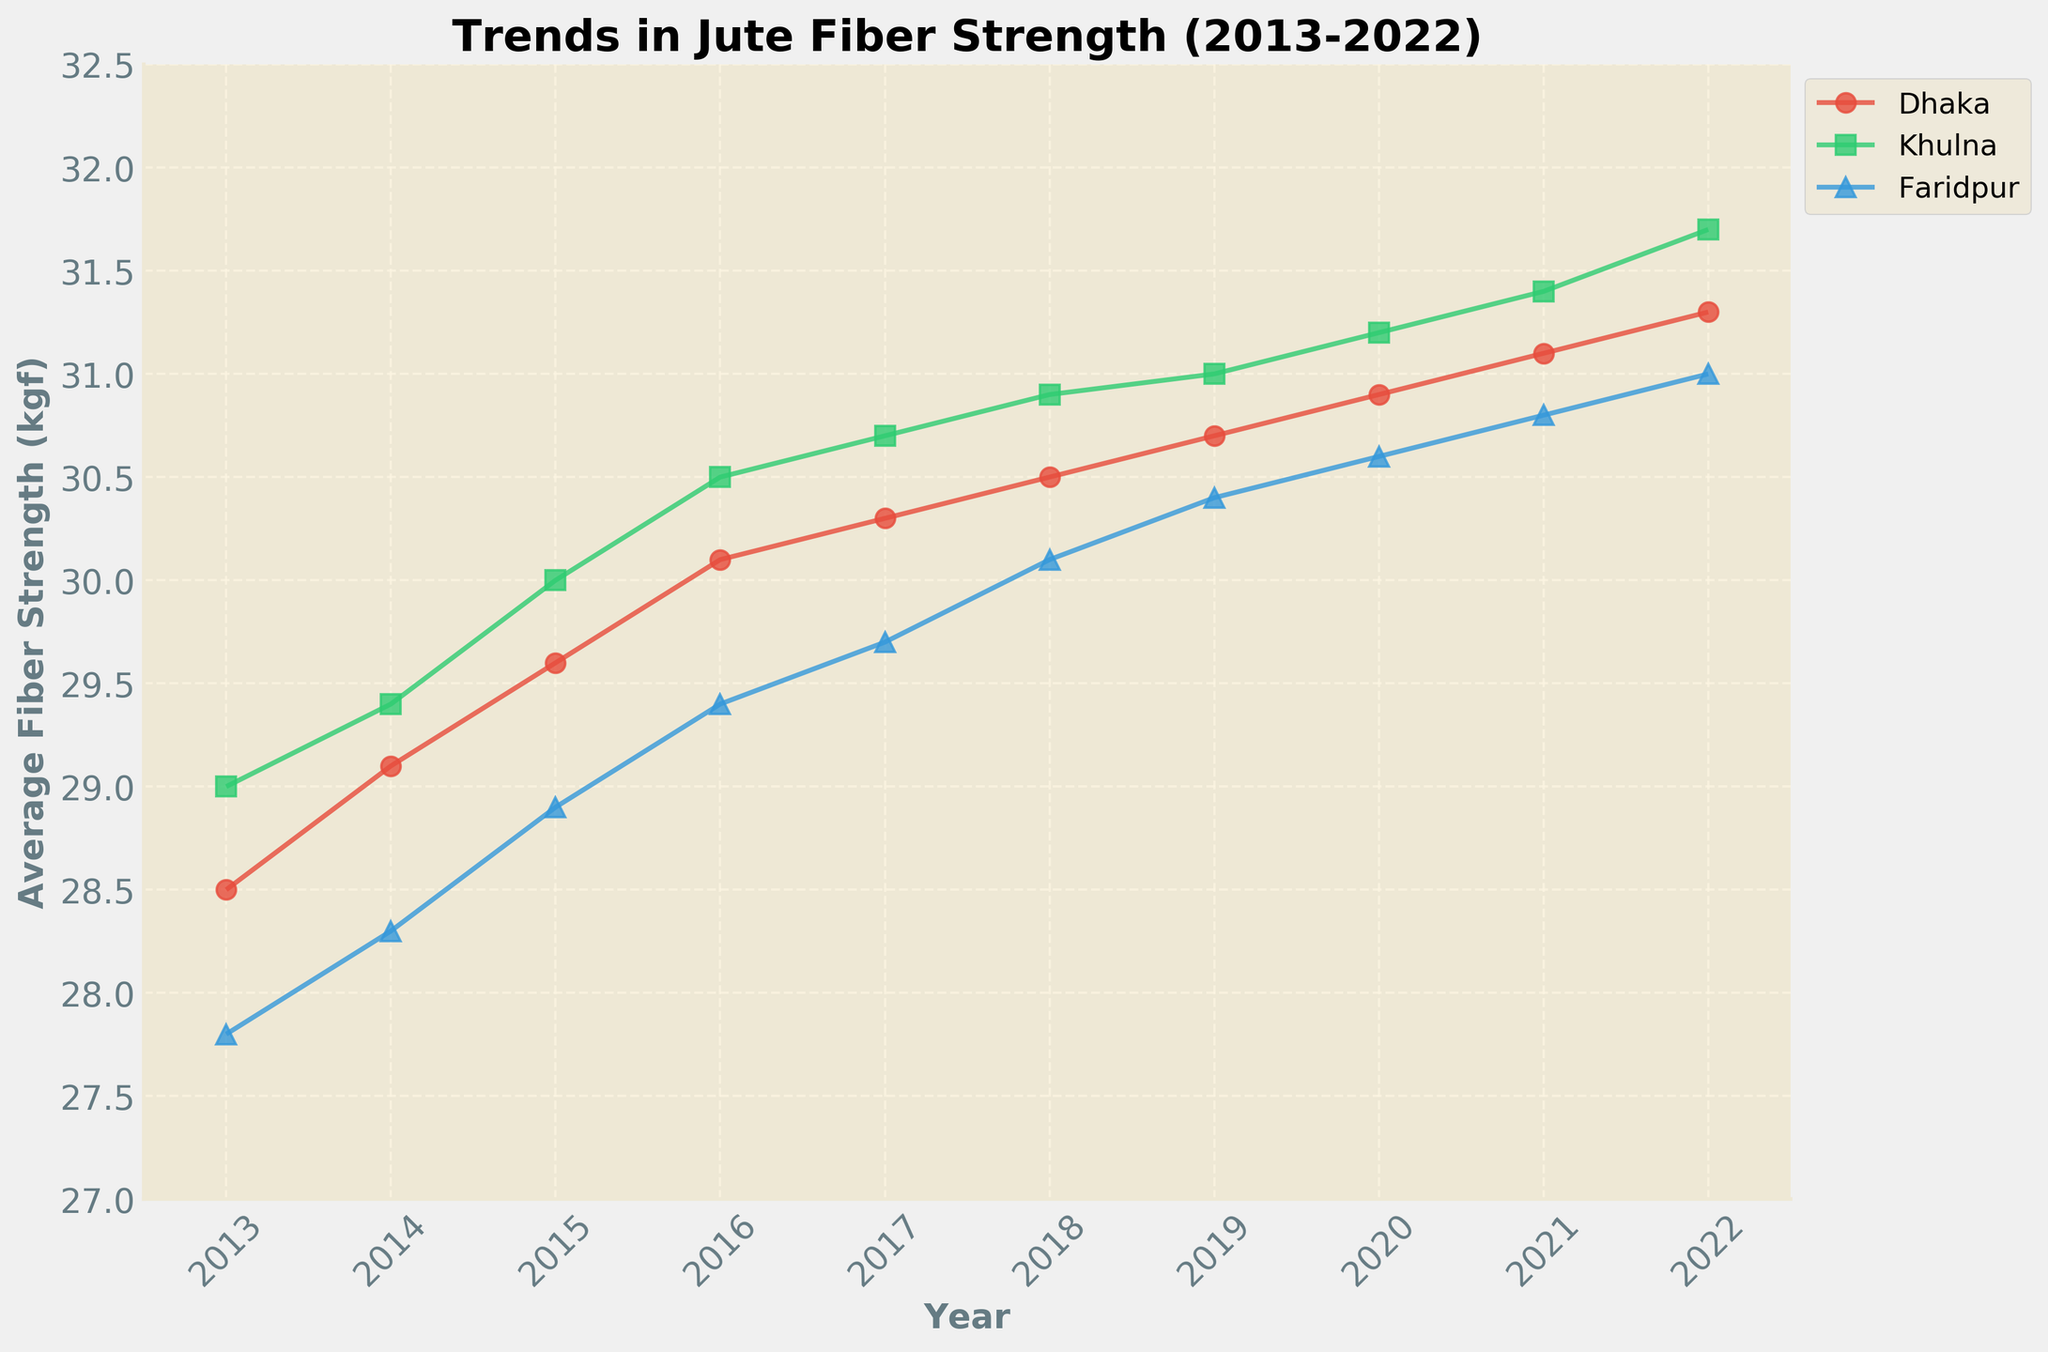What is the title of the figure? The title usually appears at the top of the figure, summarizing the main topic of the plot. In this case, the title indicates the trend of jute fiber strength over several years.
Answer: Trends in Jute Fiber Strength (2013-2022) Which region had the highest average fiber strength in 2022? To find this, observe the values for 2022 and compare the fiber strength values for Dhaka, Khulna, and Faridpur.
Answer: Khulna How did the average fiber strength in Dhaka change from 2013 to 2022? Check the data points for Dhaka in 2013 and 2022 and calculate the difference in their fiber strength.
Answer: It increased from 28.5 kgf in 2013 to 31.3 kgf in 2022 Which region shows the most consistent increase in fiber strength over the years? Look at the trend lines for each region from 2013 to 2022 and determine which one has the most uniform slope.
Answer: Khulna In which year did Faridpur first reach an average fiber strength of 30 kgf or more? Examine Faridpur’s trend line and identify the first year where the fiber strength value reaches or exceeds 30 kgf.
Answer: 2018 What is the average fiber strength in 2019 for all regions combined? Add the fiber strengths of Dhaka, Khulna, and Faridpur for 2019 and divide by 3 to get the mean value.
Answer: (30.7 + 31.0 + 30.4) / 3 ≈ 30.7 kgf Between which consecutive years did Khulna show the largest increase in average fiber strength? Calculate the difference in fiber strength for Khulna between each pair of consecutive years and find the biggest one.
Answer: 2013-2014 (0.4 kgf increase) Comparing the regions, which one had the lowest average fiber strength in 2015? Identify the 2015 data points for each region and find the one with the minimum value.
Answer: Faridpur What is the overall trend in average fiber strength for all regions from 2013 to 2022? Observe the general direction of the trend lines for each region to determine if they are increasing, decreasing, or maintaining a certain value.
Answer: Increasing By how much did the fiber strength in Khulna increase from 2016 to 2022? Subtract the 2016 fiber strength from the 2022 fiber strength for Khulna.
Answer: 31.7 - 30.5 = 1.2 kgf 